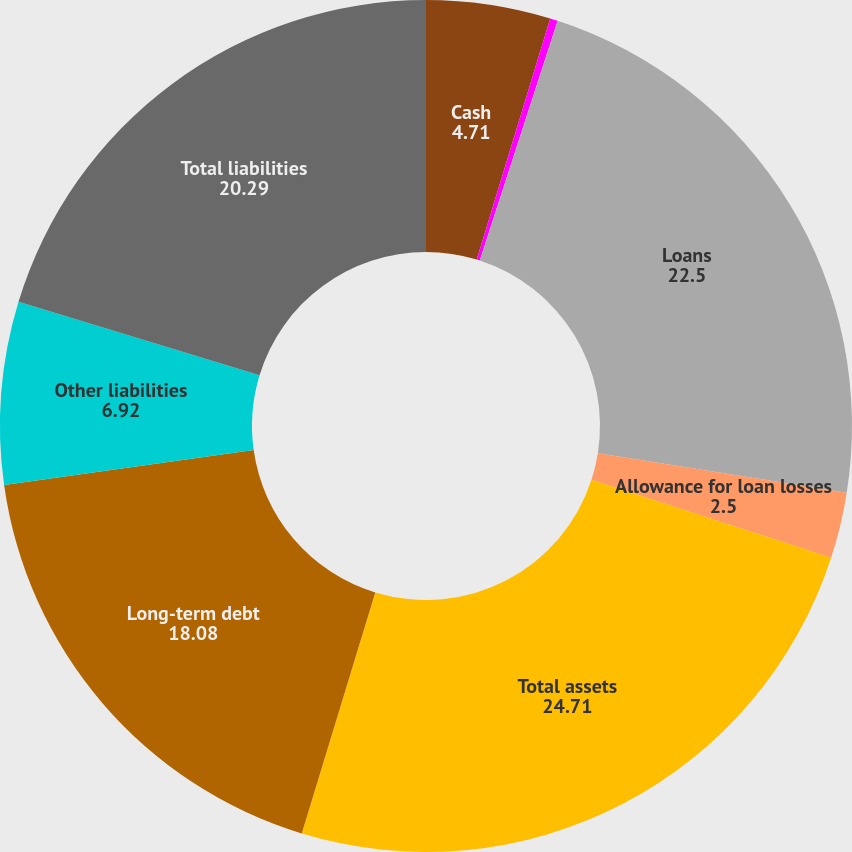<chart> <loc_0><loc_0><loc_500><loc_500><pie_chart><fcel>Cash<fcel>Available-for-sale securities<fcel>Loans<fcel>Allowance for loan losses<fcel>Total assets<fcel>Long-term debt<fcel>Other liabilities<fcel>Total liabilities<nl><fcel>4.71%<fcel>0.29%<fcel>22.5%<fcel>2.5%<fcel>24.71%<fcel>18.08%<fcel>6.92%<fcel>20.29%<nl></chart> 